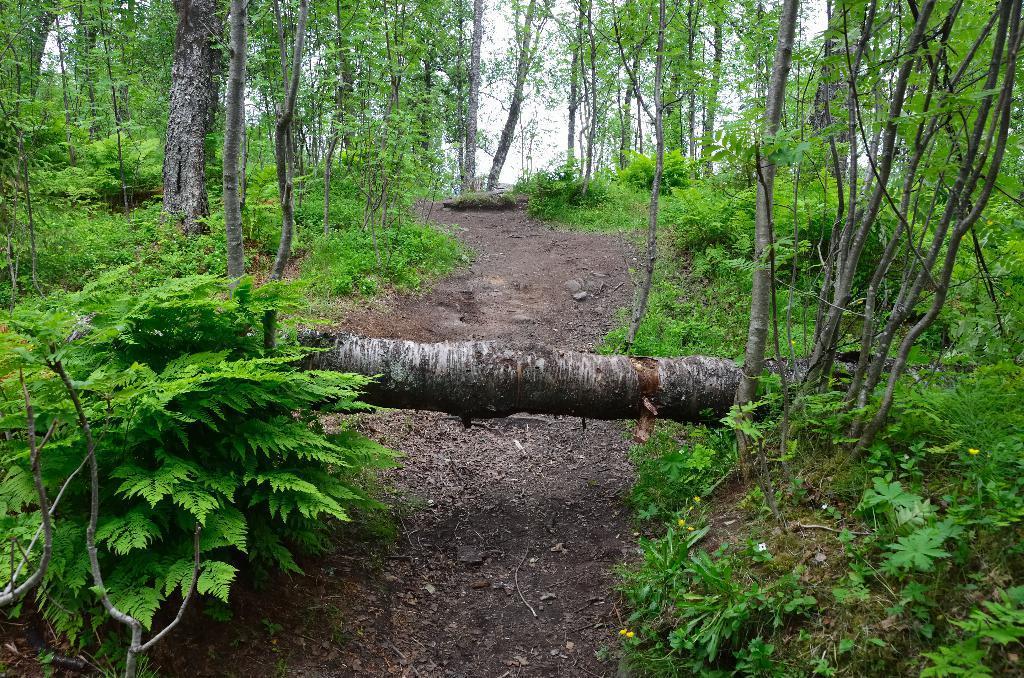Could you give a brief overview of what you see in this image? This image looks like it is clicked in a forest. At the bottom, there is a path. To the left and right, there are trees and plants in green color. 